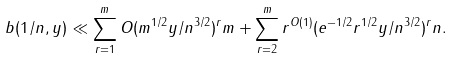<formula> <loc_0><loc_0><loc_500><loc_500>b ( 1 / n , y ) \ll \sum _ { r = 1 } ^ { m } O ( m ^ { 1 / 2 } y / n ^ { 3 / 2 } ) ^ { r } m + \sum _ { r = 2 } ^ { m } r ^ { O ( 1 ) } ( e ^ { - 1 / 2 } r ^ { 1 / 2 } y / n ^ { 3 / 2 } ) ^ { r } n .</formula> 